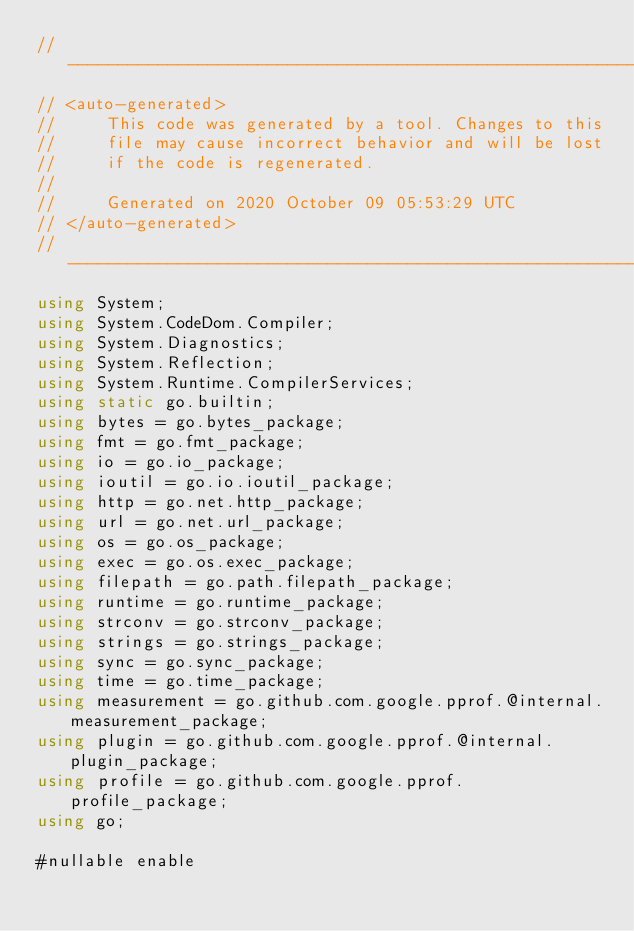<code> <loc_0><loc_0><loc_500><loc_500><_C#_>//---------------------------------------------------------
// <auto-generated>
//     This code was generated by a tool. Changes to this
//     file may cause incorrect behavior and will be lost
//     if the code is regenerated.
//
//     Generated on 2020 October 09 05:53:29 UTC
// </auto-generated>
//---------------------------------------------------------
using System;
using System.CodeDom.Compiler;
using System.Diagnostics;
using System.Reflection;
using System.Runtime.CompilerServices;
using static go.builtin;
using bytes = go.bytes_package;
using fmt = go.fmt_package;
using io = go.io_package;
using ioutil = go.io.ioutil_package;
using http = go.net.http_package;
using url = go.net.url_package;
using os = go.os_package;
using exec = go.os.exec_package;
using filepath = go.path.filepath_package;
using runtime = go.runtime_package;
using strconv = go.strconv_package;
using strings = go.strings_package;
using sync = go.sync_package;
using time = go.time_package;
using measurement = go.github.com.google.pprof.@internal.measurement_package;
using plugin = go.github.com.google.pprof.@internal.plugin_package;
using profile = go.github.com.google.pprof.profile_package;
using go;

#nullable enable
</code> 